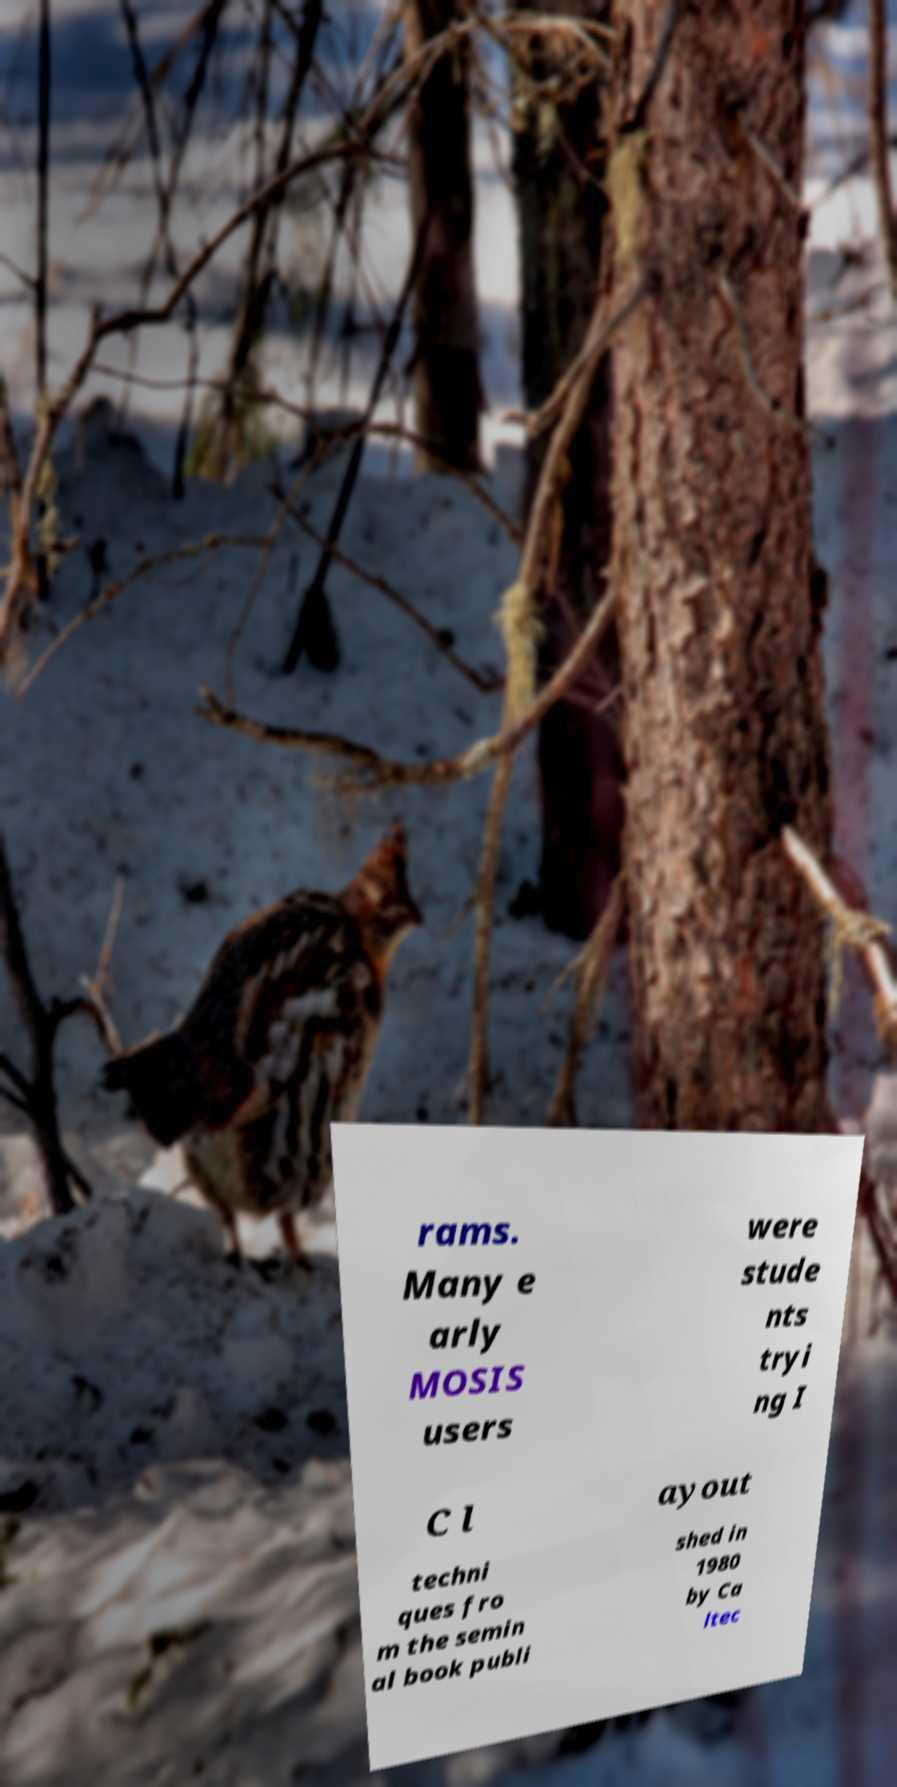Could you assist in decoding the text presented in this image and type it out clearly? rams. Many e arly MOSIS users were stude nts tryi ng I C l ayout techni ques fro m the semin al book publi shed in 1980 by Ca ltec 